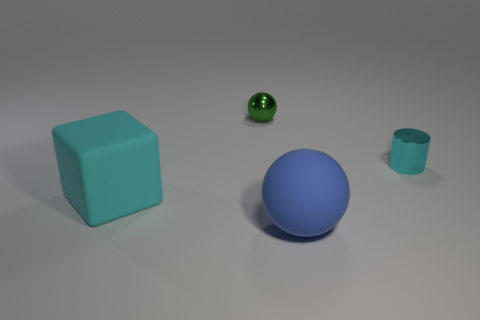How many blocks are big cyan rubber things or small cyan metal objects? In the image, there is one large cyan rubber block on the left. No small cyan metal objects are present, so the total count is one. 